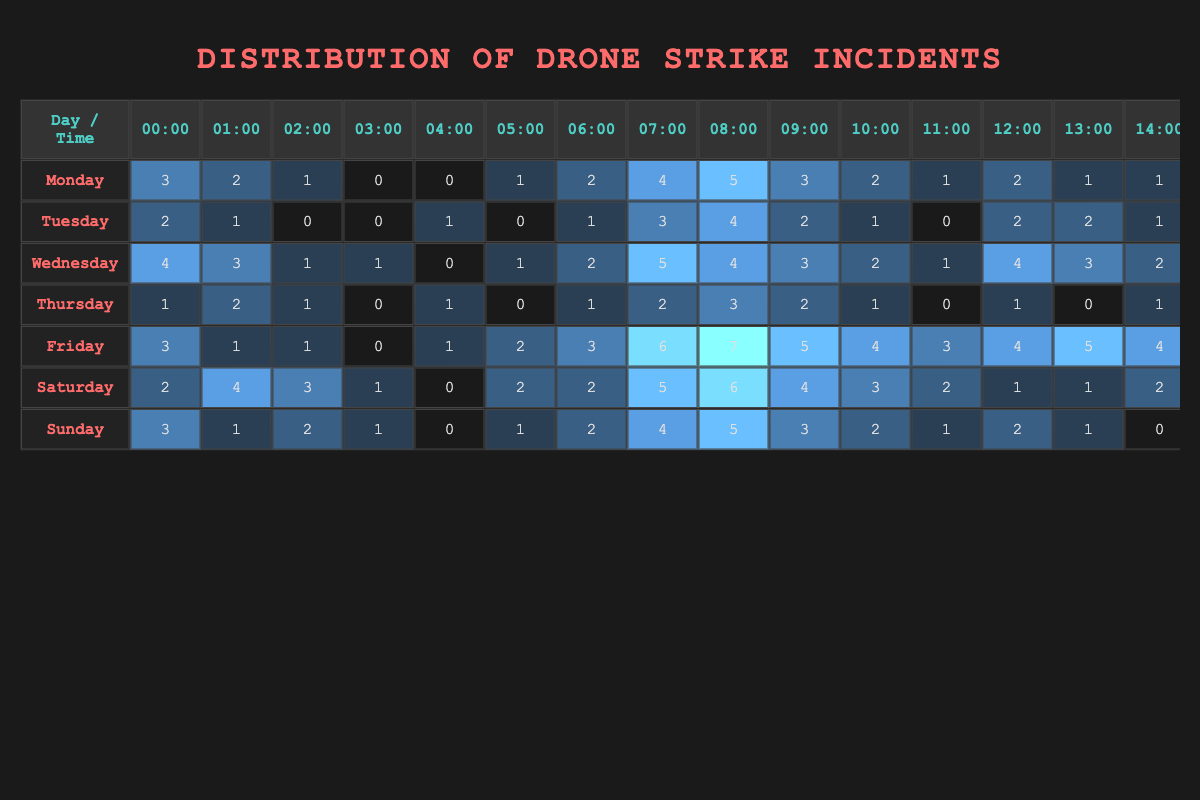What day has the highest number of drone strikes overall? By scanning the total number of strikes for each day, we can identify which day has the highest total. Adding up the values for each day: Monday (36), Tuesday (28), Wednesday (47), Thursday (17), Friday (49), Saturday (47), Sunday (30). Friday has the highest total with 49 strikes.
Answer: Friday What is the peak hour for drone strikes on Wednesdays? Looking at the row for Wednesday, we can see which hour has the highest value. The highest value is 7, recorded at 18:00.
Answer: 18:00 How many drone strikes occurred between 00:00 and 06:00 on Sundays? To find the total strikes during this time on Sunday, we sum the values for each hour: 3 (00:00) + 1 (01:00) + 2 (02:00) + 1 (03:00) + 0 (04:00) + 1 (05:00) + 2 (06:00) = 10.
Answer: 10 On which day did drone strikes occur the least during the early morning (00:00 to 06:00)? We need to calculate the morning totals from 00:00 to 06:00 for each day and compare: Monday (11), Tuesday (7), Wednesday (11), Thursday (5), Friday (10), Saturday (9), Sunday (10). Thursday has the lowest total with 5 strikes.
Answer: Thursday Is it true that more than 5 drone strikes occurred at any hour on Fridays? Looking at the Friday row, no hour exceeds 5 drone strikes; the highest is 8 recorded at 18:00. Thus, it is true that more than 5 strikes occurred.
Answer: Yes What is the average number of drone strikes per hour on Saturdays? First, we sum the total strikes for Saturday: 2 + 4 + 3 + 1 + 0 + 2 + 2 + 5 + 6 + 4 + 3 + 2 + 1 + 1 + 2 + 3 + 4 + 5 + 3 + 1 + 1 + 0 + 1 + 2 =  60. Then we divide this by 24 (the number of hours in a day): 60/24 = 2.5.
Answer: 2.5 Which day has the second highest number of drone strikes, and what is that number? Looking at the total for each day, we find: Monday (36), Tuesday (28), Wednesday (47), Thursday (17), Friday (49), Saturday (47), and Sunday (30). The second-highest day is Wednesday with 47 strikes.
Answer: Wednesday, 47 How many strikes occurred from 12:00 to 18:00 on Thursdays? Adding the values from 12:00 to 18:00 on Thursday: 1 (12:00) + 0 (13:00) + 1 (14:00) + 2 (15:00) + 3 (16:00) + 2 (17:00) + 1 (18:00) = 10 strikes.
Answer: 10 